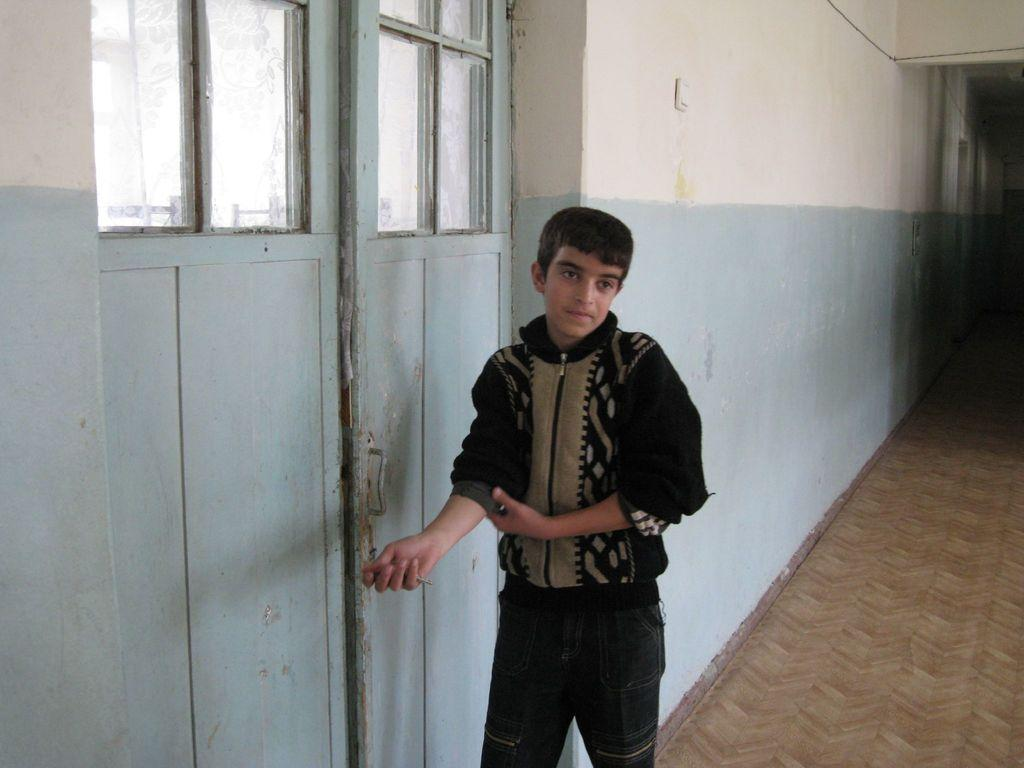Who is the main subject in the image? There is a boy in the image. What can be seen in the background of the image? There is a wall and a door in the background of the image. Where is the carpet located in the image? The carpet is in the right bottom of the image. What type of crime is being committed in the image? There is no indication of a crime being committed in the image. Can you describe the iron used by the boy in the image? There is no iron present in the image. 